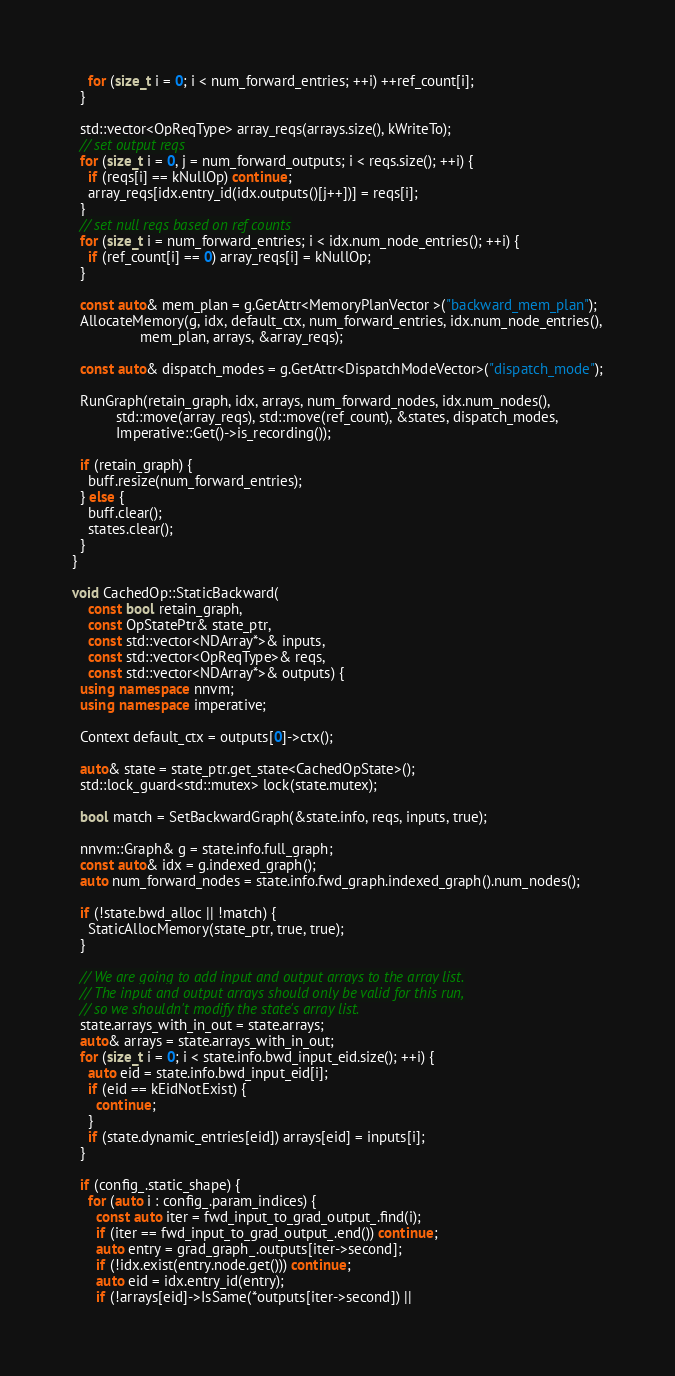<code> <loc_0><loc_0><loc_500><loc_500><_C++_>    for (size_t i = 0; i < num_forward_entries; ++i) ++ref_count[i];
  }

  std::vector<OpReqType> array_reqs(arrays.size(), kWriteTo);
  // set output reqs
  for (size_t i = 0, j = num_forward_outputs; i < reqs.size(); ++i) {
    if (reqs[i] == kNullOp) continue;
    array_reqs[idx.entry_id(idx.outputs()[j++])] = reqs[i];
  }
  // set null reqs based on ref counts
  for (size_t i = num_forward_entries; i < idx.num_node_entries(); ++i) {
    if (ref_count[i] == 0) array_reqs[i] = kNullOp;
  }

  const auto& mem_plan = g.GetAttr<MemoryPlanVector >("backward_mem_plan");
  AllocateMemory(g, idx, default_ctx, num_forward_entries, idx.num_node_entries(),
                 mem_plan, arrays, &array_reqs);

  const auto& dispatch_modes = g.GetAttr<DispatchModeVector>("dispatch_mode");

  RunGraph(retain_graph, idx, arrays, num_forward_nodes, idx.num_nodes(),
           std::move(array_reqs), std::move(ref_count), &states, dispatch_modes,
           Imperative::Get()->is_recording());

  if (retain_graph) {
    buff.resize(num_forward_entries);
  } else {
    buff.clear();
    states.clear();
  }
}

void CachedOp::StaticBackward(
    const bool retain_graph,
    const OpStatePtr& state_ptr,
    const std::vector<NDArray*>& inputs,
    const std::vector<OpReqType>& reqs,
    const std::vector<NDArray*>& outputs) {
  using namespace nnvm;
  using namespace imperative;

  Context default_ctx = outputs[0]->ctx();

  auto& state = state_ptr.get_state<CachedOpState>();
  std::lock_guard<std::mutex> lock(state.mutex);

  bool match = SetBackwardGraph(&state.info, reqs, inputs, true);

  nnvm::Graph& g = state.info.full_graph;
  const auto& idx = g.indexed_graph();
  auto num_forward_nodes = state.info.fwd_graph.indexed_graph().num_nodes();

  if (!state.bwd_alloc || !match) {
    StaticAllocMemory(state_ptr, true, true);
  }

  // We are going to add input and output arrays to the array list.
  // The input and output arrays should only be valid for this run,
  // so we shouldn't modify the state's array list.
  state.arrays_with_in_out = state.arrays;
  auto& arrays = state.arrays_with_in_out;
  for (size_t i = 0; i < state.info.bwd_input_eid.size(); ++i) {
    auto eid = state.info.bwd_input_eid[i];
    if (eid == kEidNotExist) {
      continue;
    }
    if (state.dynamic_entries[eid]) arrays[eid] = inputs[i];
  }

  if (config_.static_shape) {
    for (auto i : config_.param_indices) {
      const auto iter = fwd_input_to_grad_output_.find(i);
      if (iter == fwd_input_to_grad_output_.end()) continue;
      auto entry = grad_graph_.outputs[iter->second];
      if (!idx.exist(entry.node.get())) continue;
      auto eid = idx.entry_id(entry);
      if (!arrays[eid]->IsSame(*outputs[iter->second]) ||</code> 